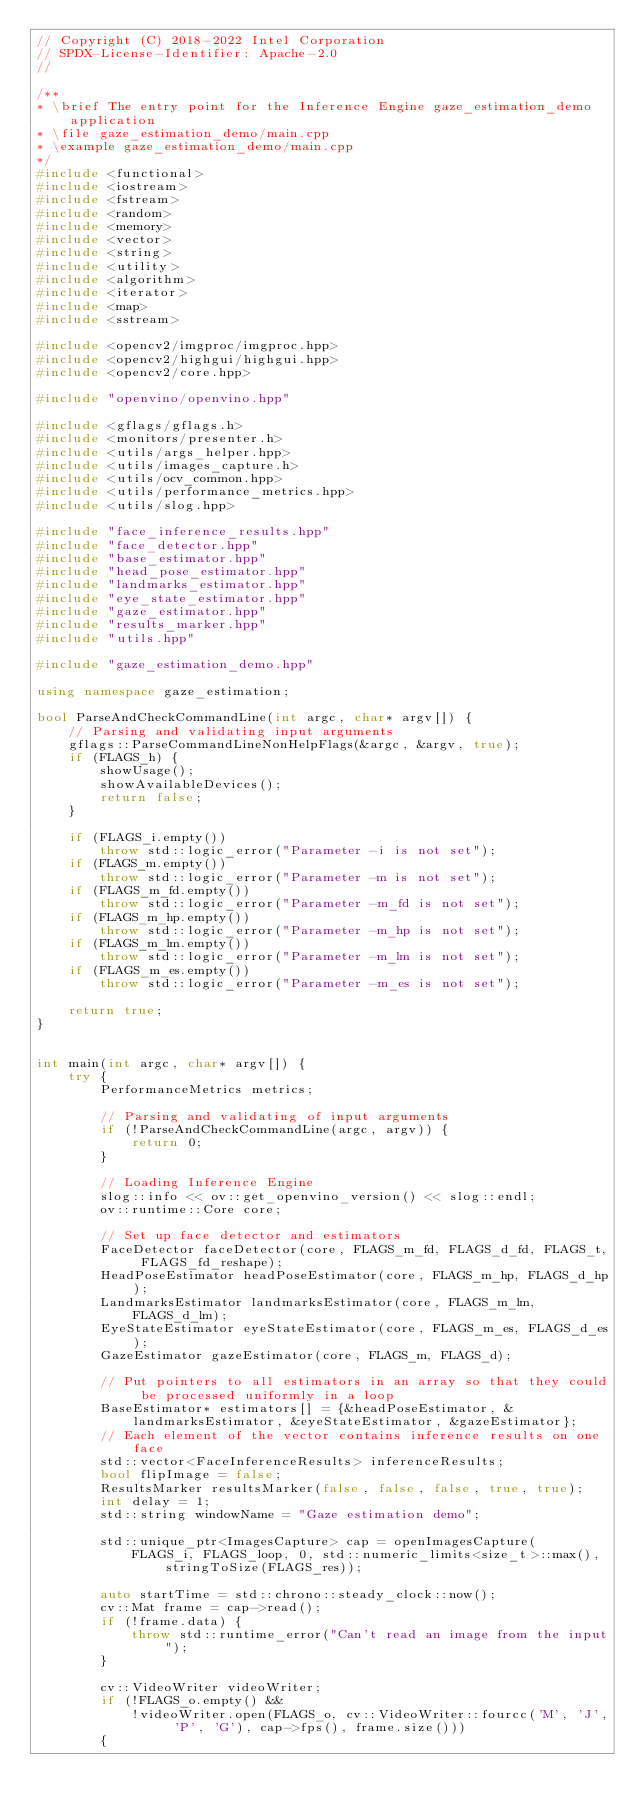<code> <loc_0><loc_0><loc_500><loc_500><_C++_>// Copyright (C) 2018-2022 Intel Corporation
// SPDX-License-Identifier: Apache-2.0
//

/**
* \brief The entry point for the Inference Engine gaze_estimation_demo application
* \file gaze_estimation_demo/main.cpp
* \example gaze_estimation_demo/main.cpp
*/
#include <functional>
#include <iostream>
#include <fstream>
#include <random>
#include <memory>
#include <vector>
#include <string>
#include <utility>
#include <algorithm>
#include <iterator>
#include <map>
#include <sstream>

#include <opencv2/imgproc/imgproc.hpp>
#include <opencv2/highgui/highgui.hpp>
#include <opencv2/core.hpp>

#include "openvino/openvino.hpp"

#include <gflags/gflags.h>
#include <monitors/presenter.h>
#include <utils/args_helper.hpp>
#include <utils/images_capture.h>
#include <utils/ocv_common.hpp>
#include <utils/performance_metrics.hpp>
#include <utils/slog.hpp>

#include "face_inference_results.hpp"
#include "face_detector.hpp"
#include "base_estimator.hpp"
#include "head_pose_estimator.hpp"
#include "landmarks_estimator.hpp"
#include "eye_state_estimator.hpp"
#include "gaze_estimator.hpp"
#include "results_marker.hpp"
#include "utils.hpp"

#include "gaze_estimation_demo.hpp"

using namespace gaze_estimation;

bool ParseAndCheckCommandLine(int argc, char* argv[]) {
    // Parsing and validating input arguments
    gflags::ParseCommandLineNonHelpFlags(&argc, &argv, true);
    if (FLAGS_h) {
        showUsage();
        showAvailableDevices();
        return false;
    }

    if (FLAGS_i.empty())
        throw std::logic_error("Parameter -i is not set");
    if (FLAGS_m.empty())
        throw std::logic_error("Parameter -m is not set");
    if (FLAGS_m_fd.empty())
        throw std::logic_error("Parameter -m_fd is not set");
    if (FLAGS_m_hp.empty())
        throw std::logic_error("Parameter -m_hp is not set");
    if (FLAGS_m_lm.empty())
        throw std::logic_error("Parameter -m_lm is not set");
    if (FLAGS_m_es.empty())
        throw std::logic_error("Parameter -m_es is not set");

    return true;
}


int main(int argc, char* argv[]) {
    try {
        PerformanceMetrics metrics;

        // Parsing and validating of input arguments
        if (!ParseAndCheckCommandLine(argc, argv)) {
            return 0;
        }

        // Loading Inference Engine
        slog::info << ov::get_openvino_version() << slog::endl;
        ov::runtime::Core core;

        // Set up face detector and estimators
        FaceDetector faceDetector(core, FLAGS_m_fd, FLAGS_d_fd, FLAGS_t, FLAGS_fd_reshape);
        HeadPoseEstimator headPoseEstimator(core, FLAGS_m_hp, FLAGS_d_hp);
        LandmarksEstimator landmarksEstimator(core, FLAGS_m_lm, FLAGS_d_lm);
        EyeStateEstimator eyeStateEstimator(core, FLAGS_m_es, FLAGS_d_es);
        GazeEstimator gazeEstimator(core, FLAGS_m, FLAGS_d);

        // Put pointers to all estimators in an array so that they could be processed uniformly in a loop
        BaseEstimator* estimators[] = {&headPoseEstimator, &landmarksEstimator, &eyeStateEstimator, &gazeEstimator};
        // Each element of the vector contains inference results on one face
        std::vector<FaceInferenceResults> inferenceResults;
        bool flipImage = false;
        ResultsMarker resultsMarker(false, false, false, true, true);
        int delay = 1;
        std::string windowName = "Gaze estimation demo";

        std::unique_ptr<ImagesCapture> cap = openImagesCapture(
            FLAGS_i, FLAGS_loop, 0, std::numeric_limits<size_t>::max(), stringToSize(FLAGS_res));

        auto startTime = std::chrono::steady_clock::now();
        cv::Mat frame = cap->read();
        if (!frame.data) {
            throw std::runtime_error("Can't read an image from the input");
        }

        cv::VideoWriter videoWriter;
        if (!FLAGS_o.empty() &&
            !videoWriter.open(FLAGS_o, cv::VideoWriter::fourcc('M', 'J', 'P', 'G'), cap->fps(), frame.size()))
        {</code> 